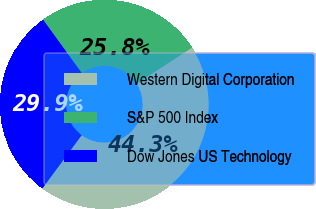<chart> <loc_0><loc_0><loc_500><loc_500><pie_chart><fcel>Western Digital Corporation<fcel>S&P 500 Index<fcel>Dow Jones US Technology<nl><fcel>44.25%<fcel>25.84%<fcel>29.9%<nl></chart> 